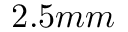<formula> <loc_0><loc_0><loc_500><loc_500>2 . 5 m m</formula> 